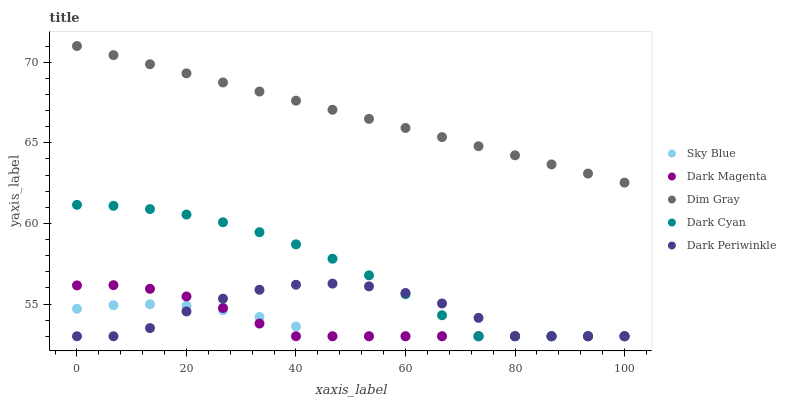Does Sky Blue have the minimum area under the curve?
Answer yes or no. Yes. Does Dim Gray have the maximum area under the curve?
Answer yes or no. Yes. Does Dim Gray have the minimum area under the curve?
Answer yes or no. No. Does Sky Blue have the maximum area under the curve?
Answer yes or no. No. Is Dim Gray the smoothest?
Answer yes or no. Yes. Is Dark Periwinkle the roughest?
Answer yes or no. Yes. Is Sky Blue the smoothest?
Answer yes or no. No. Is Sky Blue the roughest?
Answer yes or no. No. Does Dark Cyan have the lowest value?
Answer yes or no. Yes. Does Dim Gray have the lowest value?
Answer yes or no. No. Does Dim Gray have the highest value?
Answer yes or no. Yes. Does Sky Blue have the highest value?
Answer yes or no. No. Is Dark Periwinkle less than Dim Gray?
Answer yes or no. Yes. Is Dim Gray greater than Sky Blue?
Answer yes or no. Yes. Does Sky Blue intersect Dark Cyan?
Answer yes or no. Yes. Is Sky Blue less than Dark Cyan?
Answer yes or no. No. Is Sky Blue greater than Dark Cyan?
Answer yes or no. No. Does Dark Periwinkle intersect Dim Gray?
Answer yes or no. No. 